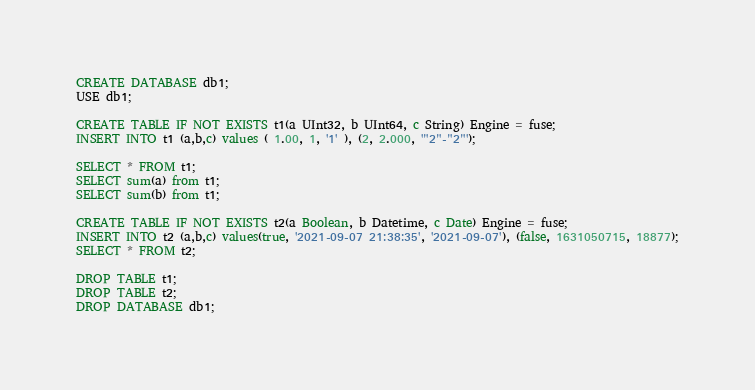Convert code to text. <code><loc_0><loc_0><loc_500><loc_500><_SQL_>CREATE DATABASE db1;
USE db1;

CREATE TABLE IF NOT EXISTS t1(a UInt32, b UInt64, c String) Engine = fuse;
INSERT INTO t1 (a,b,c) values ( 1.00, 1, '1' ), (2, 2.000, '"2"-"2"');

SELECT * FROM t1;
SELECT sum(a) from t1;
SELECT sum(b) from t1;

CREATE TABLE IF NOT EXISTS t2(a Boolean, b Datetime, c Date) Engine = fuse;
INSERT INTO t2 (a,b,c) values(true, '2021-09-07 21:38:35', '2021-09-07'), (false, 1631050715, 18877);
SELECT * FROM t2;

DROP TABLE t1;
DROP TABLE t2;
DROP DATABASE db1;
</code> 